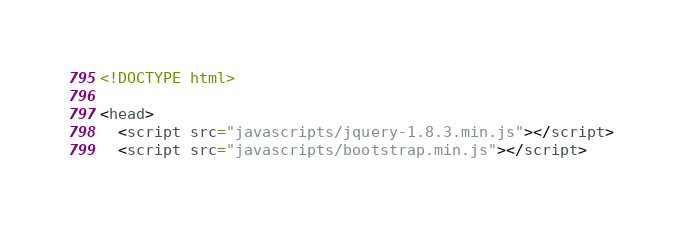<code> <loc_0><loc_0><loc_500><loc_500><_HTML_><!DOCTYPE html>

<head>
  <script src="javascripts/jquery-1.8.3.min.js"></script>
  <script src="javascripts/bootstrap.min.js"></script></code> 